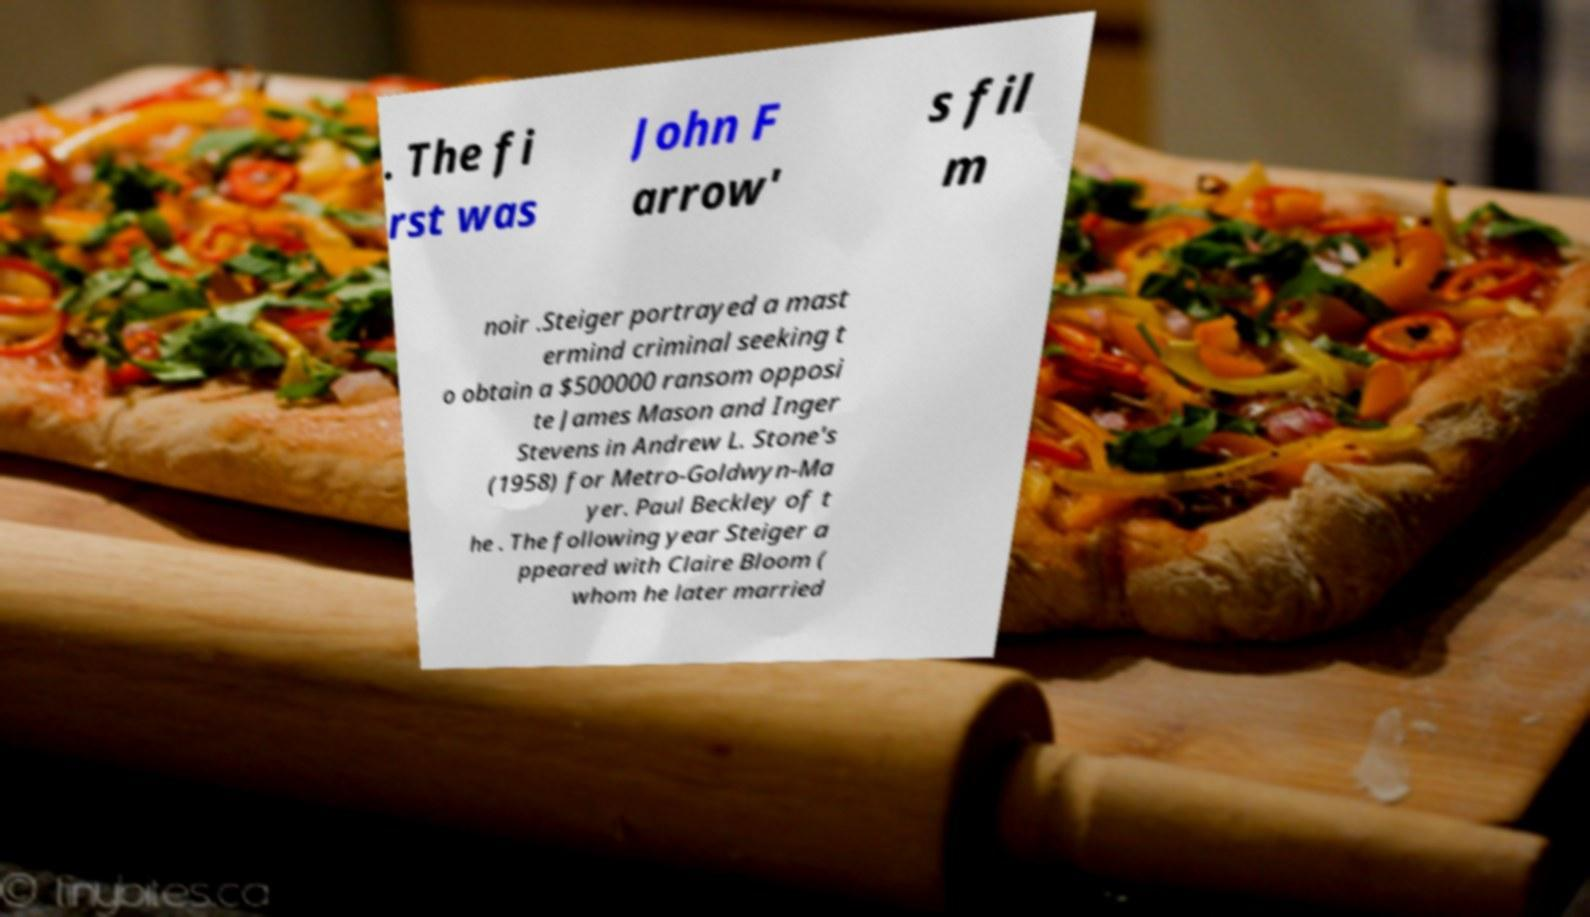Can you read and provide the text displayed in the image?This photo seems to have some interesting text. Can you extract and type it out for me? . The fi rst was John F arrow' s fil m noir .Steiger portrayed a mast ermind criminal seeking t o obtain a $500000 ransom opposi te James Mason and Inger Stevens in Andrew L. Stone's (1958) for Metro-Goldwyn-Ma yer. Paul Beckley of t he . The following year Steiger a ppeared with Claire Bloom ( whom he later married 